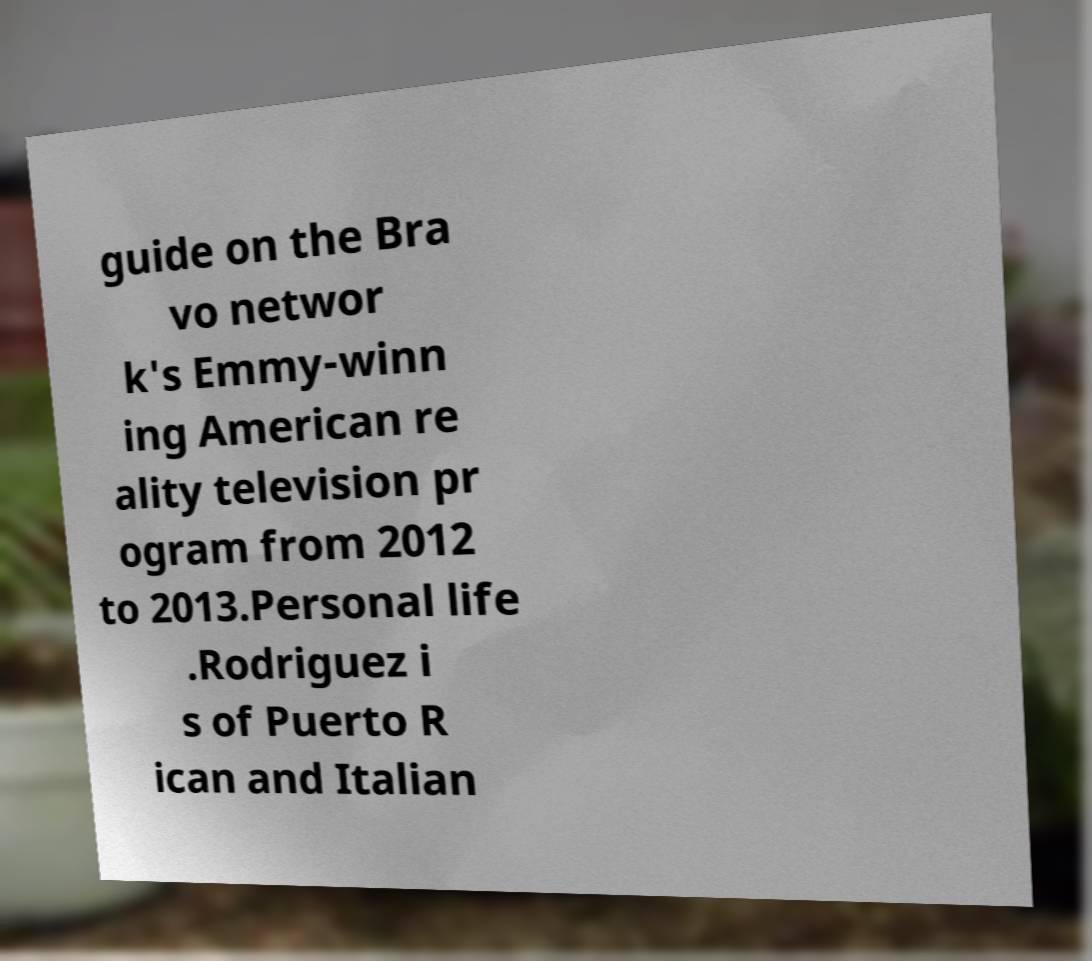What messages or text are displayed in this image? I need them in a readable, typed format. guide on the Bra vo networ k's Emmy-winn ing American re ality television pr ogram from 2012 to 2013.Personal life .Rodriguez i s of Puerto R ican and Italian 